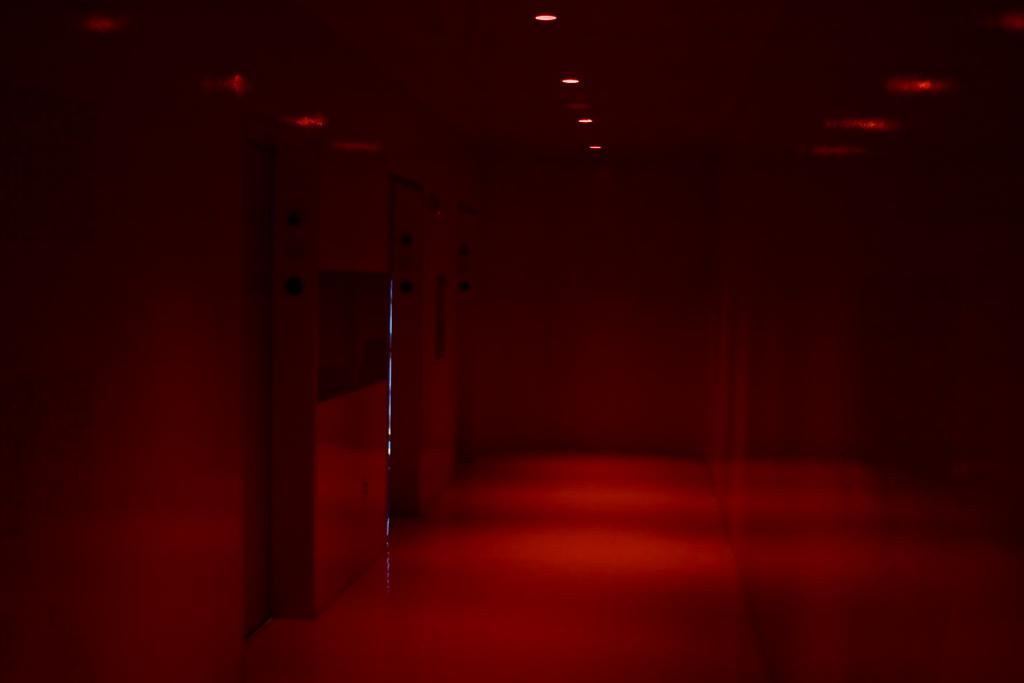What is the general lighting condition in the room in the image? The room in the image is dark. What type of lighting is present in the room in the image? There are lights present on the roof in the image. What nation is represented by the flags on the planes in the image? There are no planes or flags present in the image. How many men are visible in the image? There is no man present in the image. 